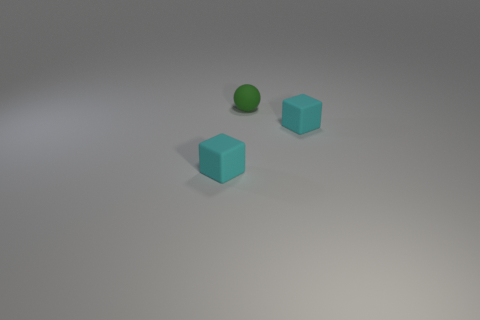Given the relative size of the blocks and ball, what can you infer about their distances from the observer? The relative size suggests that the ball and the smaller block are closer to the observer, whereas the larger block is slightly further away. This creates a sense of depth in the image. 